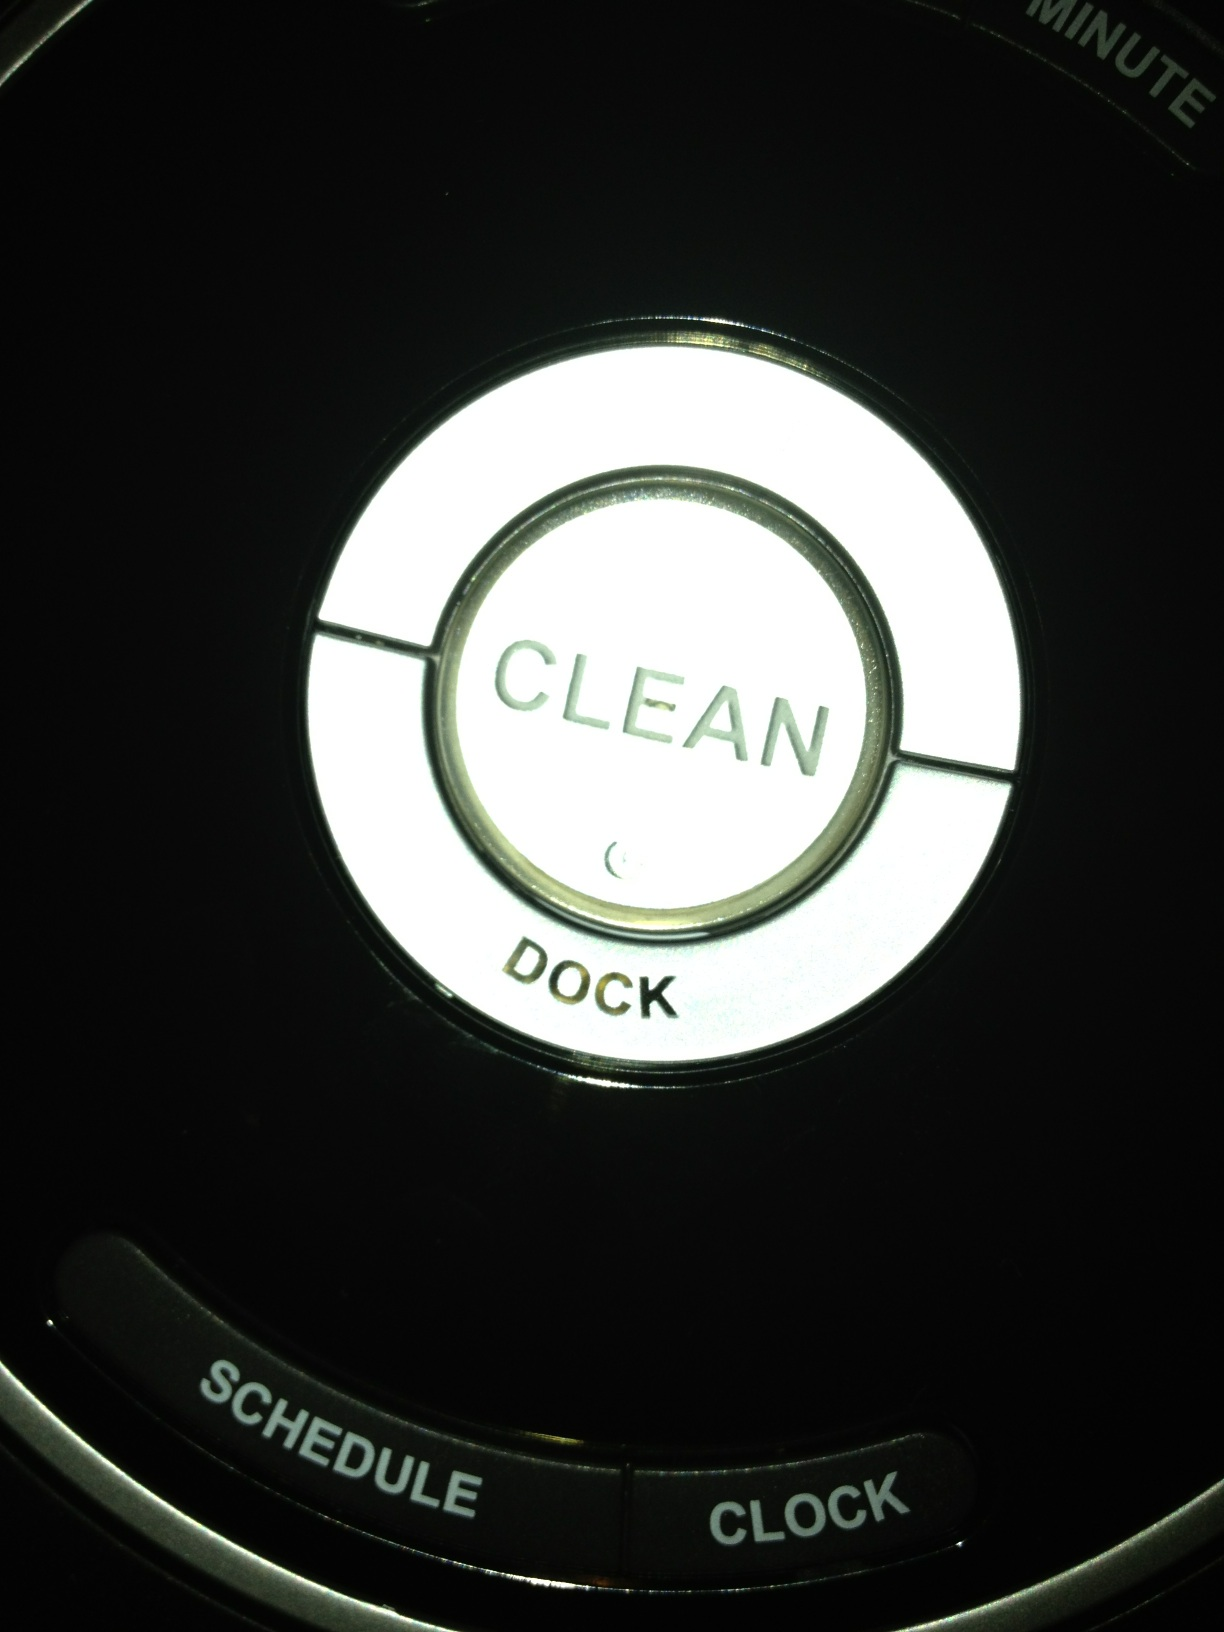There is a recessed area with three buttons in it; can you tell me what the top and bottom buttons are? Thank you. In the image provided, the top button is labeled 'CLEAN' and the bottom button is labeled 'DOCK'. These buttons likely serve to initiate cleaning and to dock the device, possibly on a robotic vacuum. 